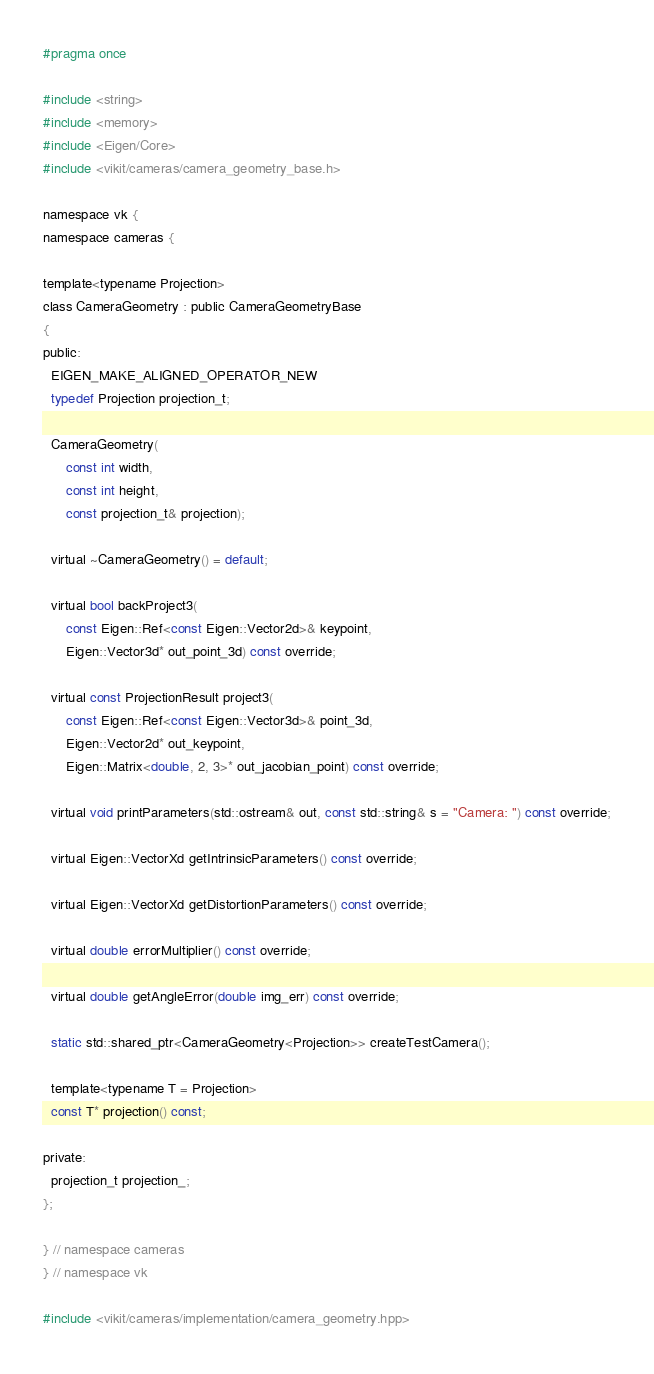Convert code to text. <code><loc_0><loc_0><loc_500><loc_500><_C_>#pragma once

#include <string>
#include <memory>
#include <Eigen/Core>
#include <vikit/cameras/camera_geometry_base.h>

namespace vk {
namespace cameras {

template<typename Projection>
class CameraGeometry : public CameraGeometryBase
{
public:
  EIGEN_MAKE_ALIGNED_OPERATOR_NEW
  typedef Projection projection_t;

  CameraGeometry(
      const int width,
      const int height,
      const projection_t& projection);

  virtual ~CameraGeometry() = default;

  virtual bool backProject3(
      const Eigen::Ref<const Eigen::Vector2d>& keypoint,
      Eigen::Vector3d* out_point_3d) const override;

  virtual const ProjectionResult project3(
      const Eigen::Ref<const Eigen::Vector3d>& point_3d,
      Eigen::Vector2d* out_keypoint,
      Eigen::Matrix<double, 2, 3>* out_jacobian_point) const override;

  virtual void printParameters(std::ostream& out, const std::string& s = "Camera: ") const override;

  virtual Eigen::VectorXd getIntrinsicParameters() const override;

  virtual Eigen::VectorXd getDistortionParameters() const override;

  virtual double errorMultiplier() const override;

  virtual double getAngleError(double img_err) const override;

  static std::shared_ptr<CameraGeometry<Projection>> createTestCamera();

  template<typename T = Projection>
  const T* projection() const;

private:
  projection_t projection_;
};

} // namespace cameras
} // namespace vk

#include <vikit/cameras/implementation/camera_geometry.hpp>
</code> 